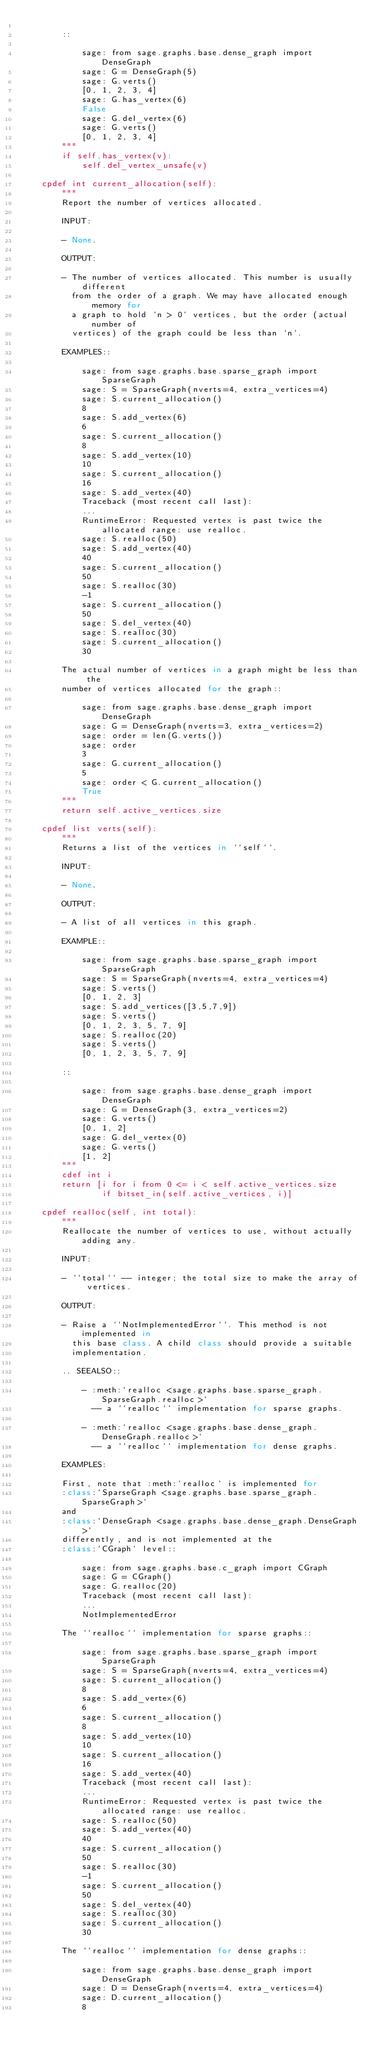Convert code to text. <code><loc_0><loc_0><loc_500><loc_500><_Cython_>
        ::

            sage: from sage.graphs.base.dense_graph import DenseGraph
            sage: G = DenseGraph(5)
            sage: G.verts()
            [0, 1, 2, 3, 4]
            sage: G.has_vertex(6)
            False
            sage: G.del_vertex(6)
            sage: G.verts()
            [0, 1, 2, 3, 4]
        """
        if self.has_vertex(v):
            self.del_vertex_unsafe(v)

    cpdef int current_allocation(self):
        """
        Report the number of vertices allocated.

        INPUT:

        - None.

        OUTPUT:

        - The number of vertices allocated. This number is usually different
          from the order of a graph. We may have allocated enough memory for
          a graph to hold `n > 0` vertices, but the order (actual number of
          vertices) of the graph could be less than `n`.

        EXAMPLES::

            sage: from sage.graphs.base.sparse_graph import SparseGraph
            sage: S = SparseGraph(nverts=4, extra_vertices=4)
            sage: S.current_allocation()
            8
            sage: S.add_vertex(6)
            6
            sage: S.current_allocation()
            8
            sage: S.add_vertex(10)
            10
            sage: S.current_allocation()
            16
            sage: S.add_vertex(40)
            Traceback (most recent call last):
            ...
            RuntimeError: Requested vertex is past twice the allocated range: use realloc.
            sage: S.realloc(50)
            sage: S.add_vertex(40)
            40
            sage: S.current_allocation()
            50
            sage: S.realloc(30)
            -1
            sage: S.current_allocation()
            50
            sage: S.del_vertex(40)
            sage: S.realloc(30)
            sage: S.current_allocation()
            30

        The actual number of vertices in a graph might be less than the
        number of vertices allocated for the graph::

            sage: from sage.graphs.base.dense_graph import DenseGraph
            sage: G = DenseGraph(nverts=3, extra_vertices=2)
            sage: order = len(G.verts())
            sage: order
            3
            sage: G.current_allocation()
            5
            sage: order < G.current_allocation()
            True
        """
        return self.active_vertices.size

    cpdef list verts(self):
        """
        Returns a list of the vertices in ``self``.

        INPUT:

        - None.

        OUTPUT:

        - A list of all vertices in this graph.

        EXAMPLE::

            sage: from sage.graphs.base.sparse_graph import SparseGraph
            sage: S = SparseGraph(nverts=4, extra_vertices=4)
            sage: S.verts()
            [0, 1, 2, 3]
            sage: S.add_vertices([3,5,7,9])
            sage: S.verts()
            [0, 1, 2, 3, 5, 7, 9]
            sage: S.realloc(20)
            sage: S.verts()
            [0, 1, 2, 3, 5, 7, 9]

        ::

            sage: from sage.graphs.base.dense_graph import DenseGraph
            sage: G = DenseGraph(3, extra_vertices=2)
            sage: G.verts()
            [0, 1, 2]
            sage: G.del_vertex(0)
            sage: G.verts()
            [1, 2]
        """
        cdef int i
        return [i for i from 0 <= i < self.active_vertices.size
                if bitset_in(self.active_vertices, i)]

    cpdef realloc(self, int total):
        """
        Reallocate the number of vertices to use, without actually adding any.

        INPUT:

        - ``total`` -- integer; the total size to make the array of vertices.

        OUTPUT:

        - Raise a ``NotImplementedError``. This method is not implemented in
          this base class. A child class should provide a suitable
          implementation.

        .. SEEALSO::

            - :meth:`realloc <sage.graphs.base.sparse_graph.SparseGraph.realloc>`
              -- a ``realloc`` implementation for sparse graphs.

            - :meth:`realloc <sage.graphs.base.dense_graph.DenseGraph.realloc>`
              -- a ``realloc`` implementation for dense graphs.

        EXAMPLES:

        First, note that :meth:`realloc` is implemented for
        :class:`SparseGraph <sage.graphs.base.sparse_graph.SparseGraph>`
        and
        :class:`DenseGraph <sage.graphs.base.dense_graph.DenseGraph>`
        differently, and is not implemented at the
        :class:`CGraph` level::

            sage: from sage.graphs.base.c_graph import CGraph
            sage: G = CGraph()
            sage: G.realloc(20)
            Traceback (most recent call last):
            ...
            NotImplementedError

        The ``realloc`` implementation for sparse graphs::

            sage: from sage.graphs.base.sparse_graph import SparseGraph
            sage: S = SparseGraph(nverts=4, extra_vertices=4)
            sage: S.current_allocation()
            8
            sage: S.add_vertex(6)
            6
            sage: S.current_allocation()
            8
            sage: S.add_vertex(10)
            10
            sage: S.current_allocation()
            16
            sage: S.add_vertex(40)
            Traceback (most recent call last):
            ...
            RuntimeError: Requested vertex is past twice the allocated range: use realloc.
            sage: S.realloc(50)
            sage: S.add_vertex(40)
            40
            sage: S.current_allocation()
            50
            sage: S.realloc(30)
            -1
            sage: S.current_allocation()
            50
            sage: S.del_vertex(40)
            sage: S.realloc(30)
            sage: S.current_allocation()
            30

        The ``realloc`` implementation for dense graphs::

            sage: from sage.graphs.base.dense_graph import DenseGraph
            sage: D = DenseGraph(nverts=4, extra_vertices=4)
            sage: D.current_allocation()
            8</code> 